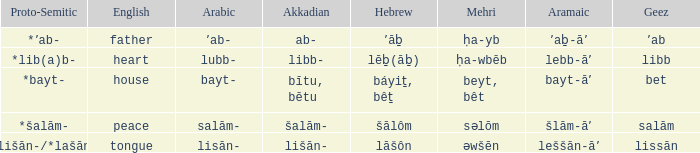If the proto-semitic is *bayt-, what are the geez? Bet. 